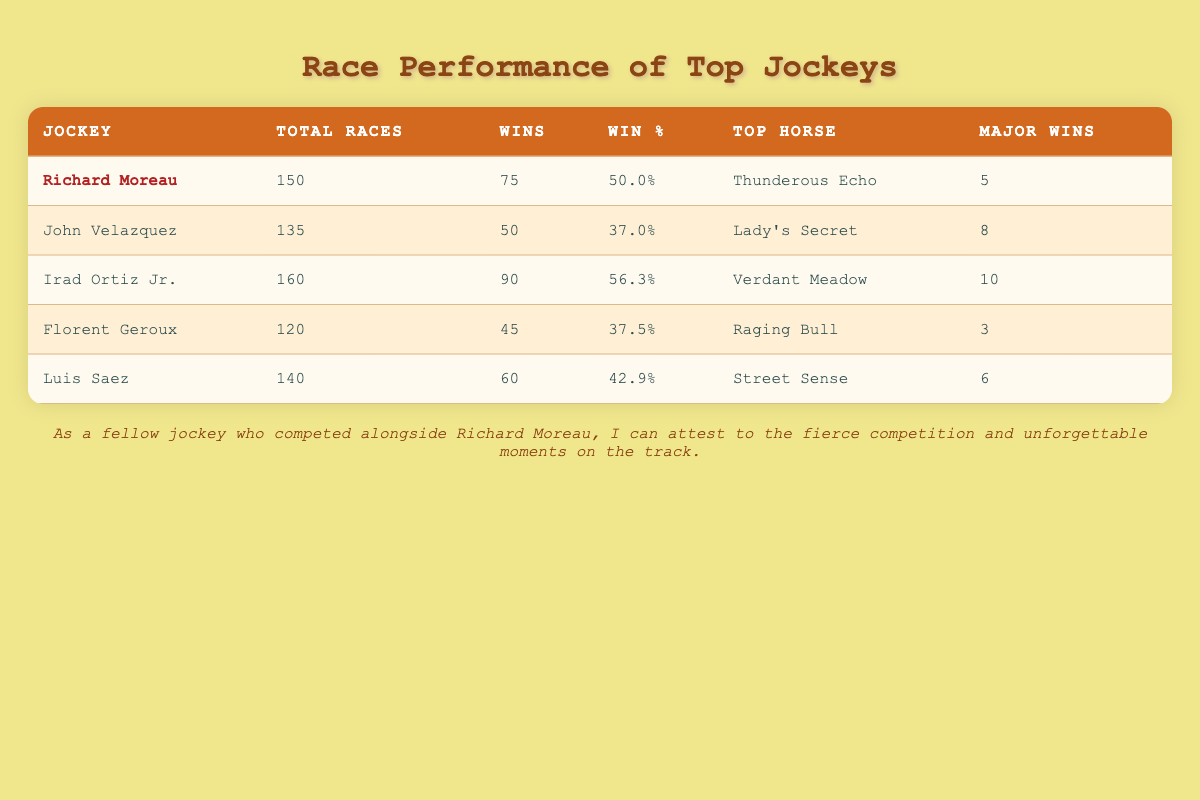What is the win percentage of Richard Moreau? To find Richard Moreau's win percentage, we refer directly to the table under his row. His win percentage is listed as 50.0%.
Answer: 50.0% Who has the highest number of major competition wins? To determine which jockey has the highest number of major competition wins, we look across the "Major Wins" column. Irad Ortiz Jr. has 10 major competition wins, which is the highest in the table.
Answer: Irad Ortiz Jr What is the average number of wins among the listed jockeys? We need to sum the number of wins of all jockeys (75 + 50 + 90 + 45 + 60 = 320) and then divide by the number of jockeys (5). The average is 320 / 5 = 64.
Answer: 64 Is Luis Saez's win percentage greater than 40%? To answer this, we check Luis Saez's win percentage in the table, which is 42.9%. Since 42.9% is indeed greater than 40%, the statement is true.
Answer: Yes Which jockey has the lowest win percentage? The win percentages for all jockeys are Richard Moreau (50.0%), John Velazquez (37.0%), Irad Ortiz Jr. (56.3%), Florent Geroux (37.5%), and Luis Saez (42.9%). Among these, John Velazquez has the lowest win percentage at 37.0%.
Answer: John Velazquez What is the difference in the total races between Irad Ortiz Jr. and Florent Geroux? Irad Ortiz Jr. has 160 total races and Florent Geroux has 120 total races. The difference is 160 - 120 = 40 total races.
Answer: 40 Did any jockey have as many wins as their win percentage suggests? Richard Moreau has 75 wins and a win percentage of 50.0%, which means he would need 75 wins out of 150 races to achieve this percentage. Since he has exactly that, the statement is true.
Answer: Yes Which jockey's top horse is "Street Sense"? By checking the "Top Horse" column, it shows that Luis Saez's top horse is "Street Sense". Hence, he is the jockey with this top horse.
Answer: Luis Saez 